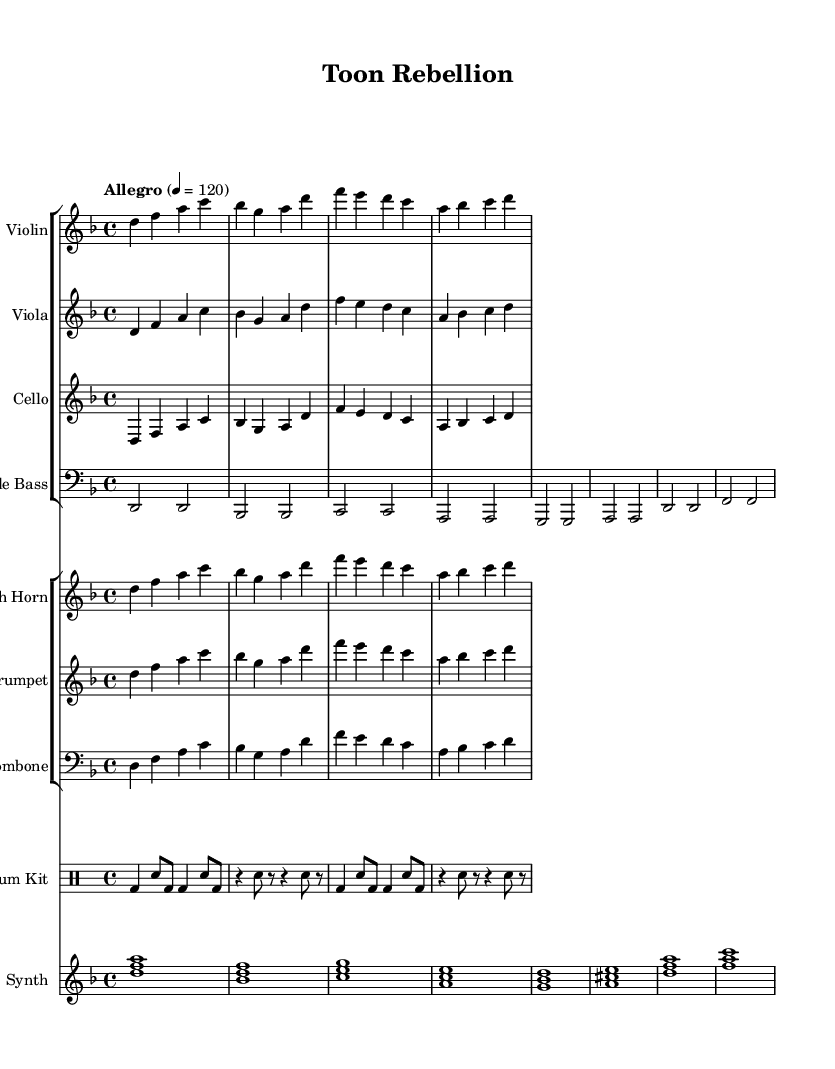What is the key signature of this music? The key signature is indicated at the beginning of the staff, showing two flats, which corresponds to D minor.
Answer: D minor What is the time signature of this music? The time signature is located at the beginning of the staff, written as 4/4, which signifies four beats per measure.
Answer: 4/4 What is the tempo marking for this piece? The tempo marking is found at the beginning, stating "Allegro" with a metronome marking of 120 beats per minute.
Answer: Allegro 120 How many different instruments are used in this score? By counting the labeled staff groups and their associated instruments, we find there are eight distinct instrument parts: Violins, Violas, Cellos, Double Bass, French Horn, Trumpet, Trombone, Drum Kit, and Synth.
Answer: Eight Which string instrument has the highest pitch range in this score? The violin staff is placed higher on the staff compared to the viola, cello, and double bass, indicating it plays the highest pitch range.
Answer: Violin What musical elements indicate a hip-hop influence in this piece? The presence of a drum kit with syncopated rhythms, alongside the synthesizer, reflects typical hip-hop elements, suggesting that this fusion incorporates a contemporary rhythmic style.
Answer: Drum Kit and Synth 